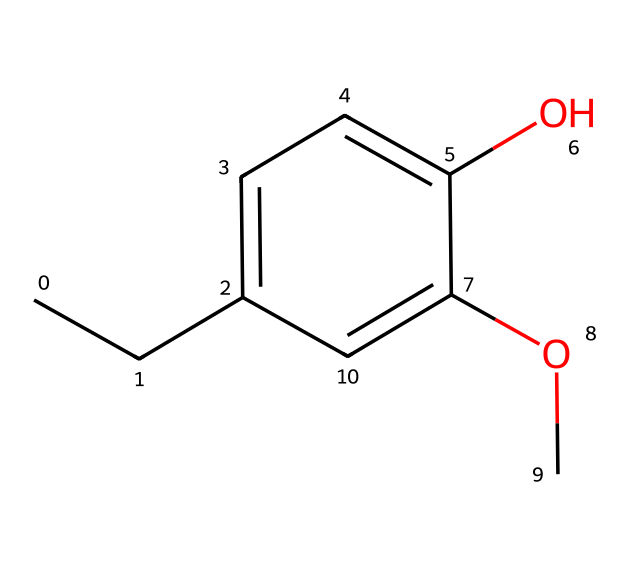What is the molecular formula of eugenol? To find the molecular formula, we count the number of each type of atom present in the given SMILES representation. From the structure, we identify carbon (C), hydrogen (H), and oxygen (O) atoms. There are 10 carbons, 12 hydrogens, and 2 oxygens. Therefore, the molecular formula is C10H12O2.
Answer: C10H12O2 How many aromatic rings are present in eugenol? By analyzing the structure, we observe the presence of a benzene ring in the compound. An aromatic ring is characterized by a cyclic structure with alternating double bonds, which is evident here. Since only one benzene ring is present, we conclude that there is one aromatic ring.
Answer: 1 What functional groups are present in eugenol? Examining the chemical structure reveals the presence of a hydroxyl group (-OH) and a methoxy group (-OCH3). The hydroxyl group contributes the phenolic character, while the methoxy group is identified as an ether derived from the aromatic system. Thus, the compound contains a phenol and an ether functional group.
Answer: phenol, ether Is eugenol more likely to be hydrophilic or hydrophobic? The presence of the hydroxyl group indicates a hydrophilic aspect due to the ability to form hydrogen bonds with water. However, the larger hydrocarbon part may contribute some hydrophobic character. Despite that, the overall influence of the -OH group on solubility tilts towards hydrophilicity.
Answer: hydrophilic What type of reaction might eugenol undergo due to its structure? Given that eugenol features a hydroxyl group and an aromatic ring, it is prone to electrophilic substitution reactions, which are typical for phenolic compounds. Additionally, the methoxy group can also undergo methylation or demethylation reactions under certain conditions. Therefore, eugenol is likely to undergo electrophilic substitution.
Answer: electrophilic substitution How many oxygen atoms are in eugenol? By inspecting the SMILES representation, we can directly count the number of oxygen atoms in the structure. The representation clearly shows two oxygen atoms: one from the hydroxyl group and one from the methoxy group. Therefore, eugenol contains two oxygen atoms.
Answer: 2 